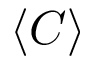Convert formula to latex. <formula><loc_0><loc_0><loc_500><loc_500>\langle C \rangle</formula> 